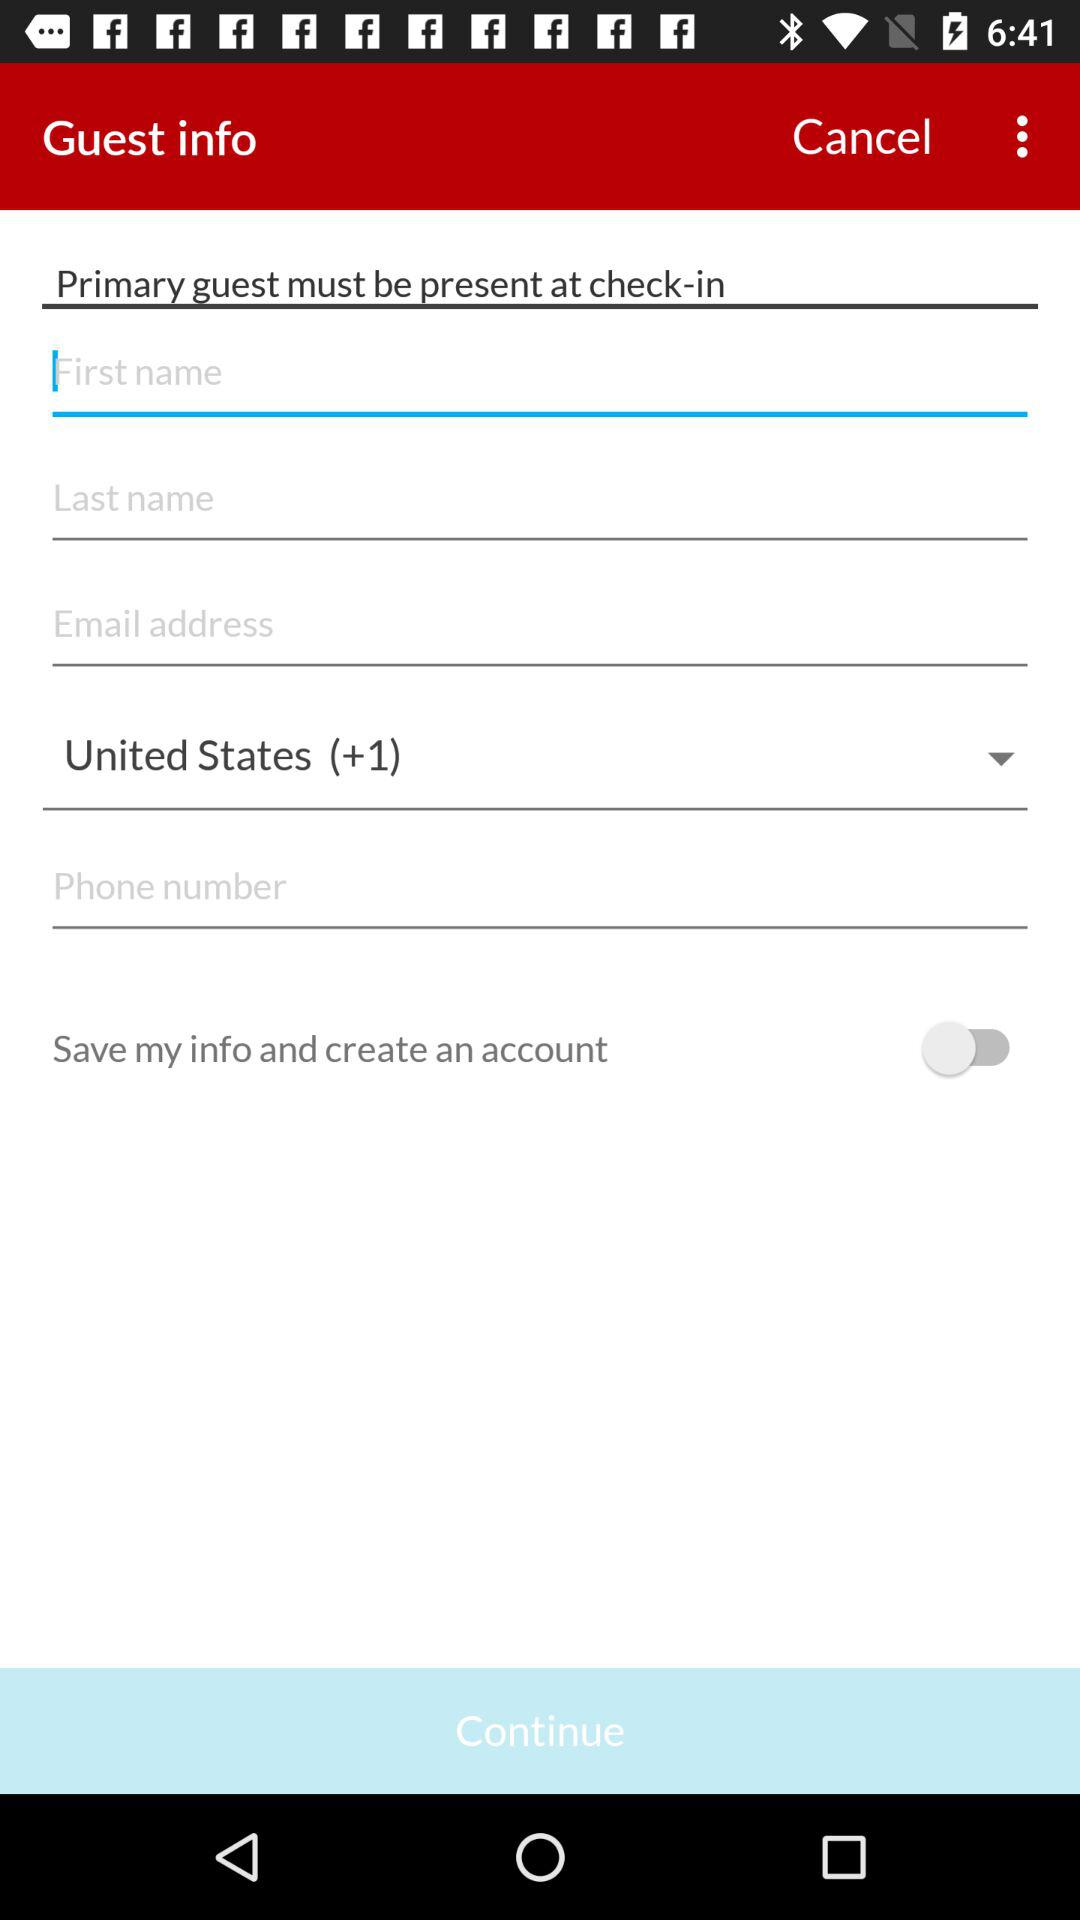Which country has been selected? The country that has been selected is the United States. 